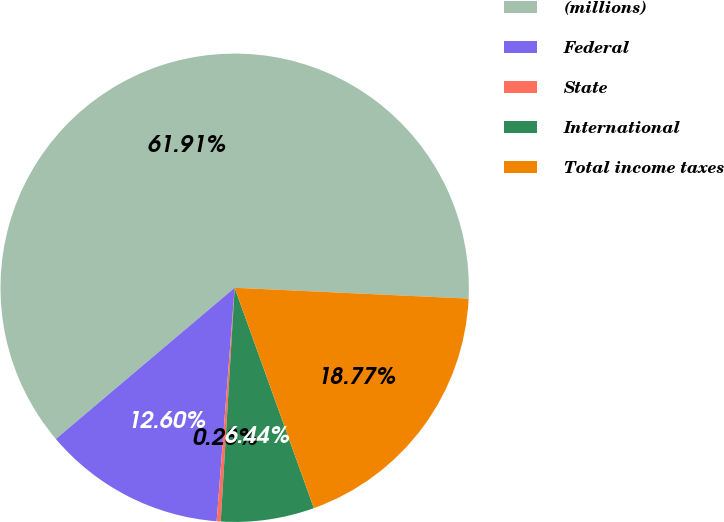<chart> <loc_0><loc_0><loc_500><loc_500><pie_chart><fcel>(millions)<fcel>Federal<fcel>State<fcel>International<fcel>Total income taxes<nl><fcel>61.91%<fcel>12.6%<fcel>0.28%<fcel>6.44%<fcel>18.77%<nl></chart> 